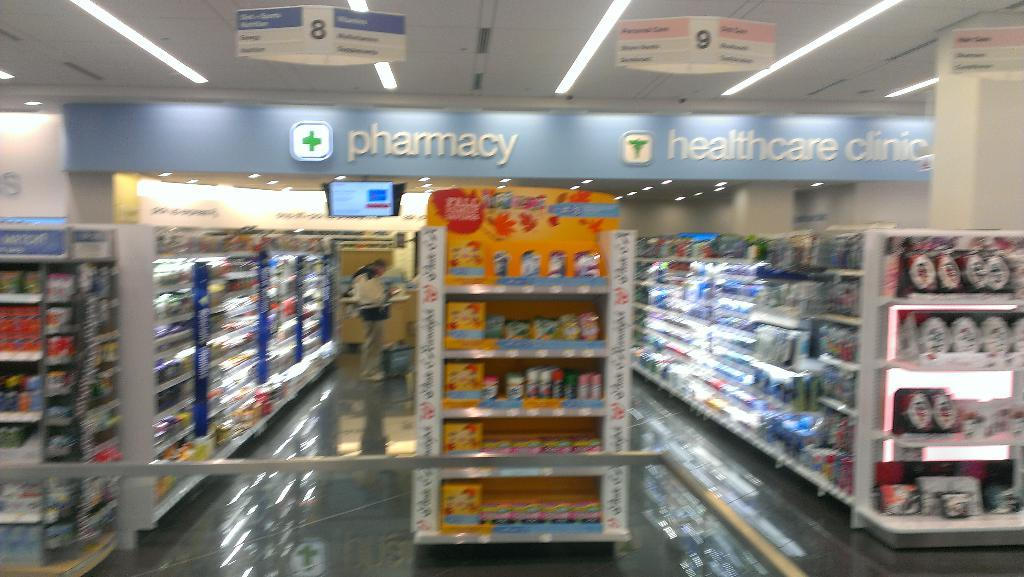Provide a one-sentence caption for the provided image. The interior of a pharmacy that also features a healthcare clinic. 